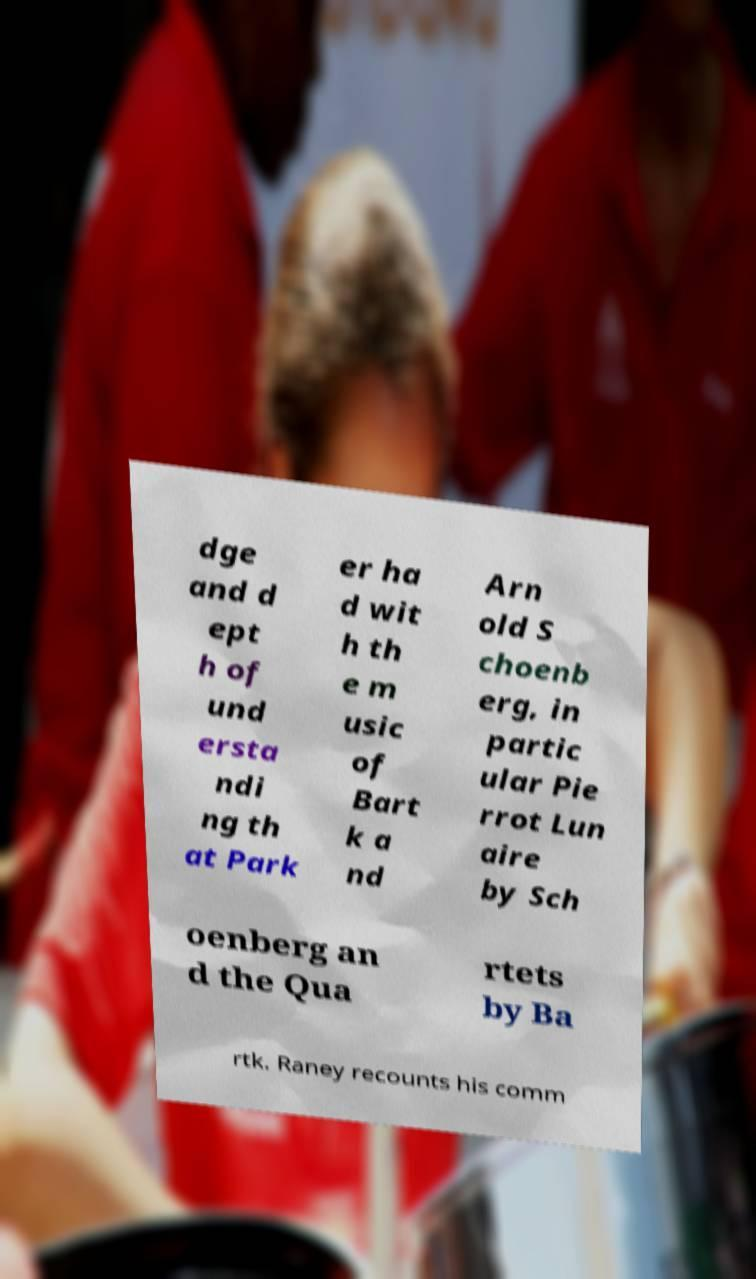For documentation purposes, I need the text within this image transcribed. Could you provide that? dge and d ept h of und ersta ndi ng th at Park er ha d wit h th e m usic of Bart k a nd Arn old S choenb erg, in partic ular Pie rrot Lun aire by Sch oenberg an d the Qua rtets by Ba rtk. Raney recounts his comm 